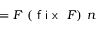Convert formula to latex. <formula><loc_0><loc_0><loc_500><loc_500>= F \ ( { f i x } \ F ) \ n</formula> 